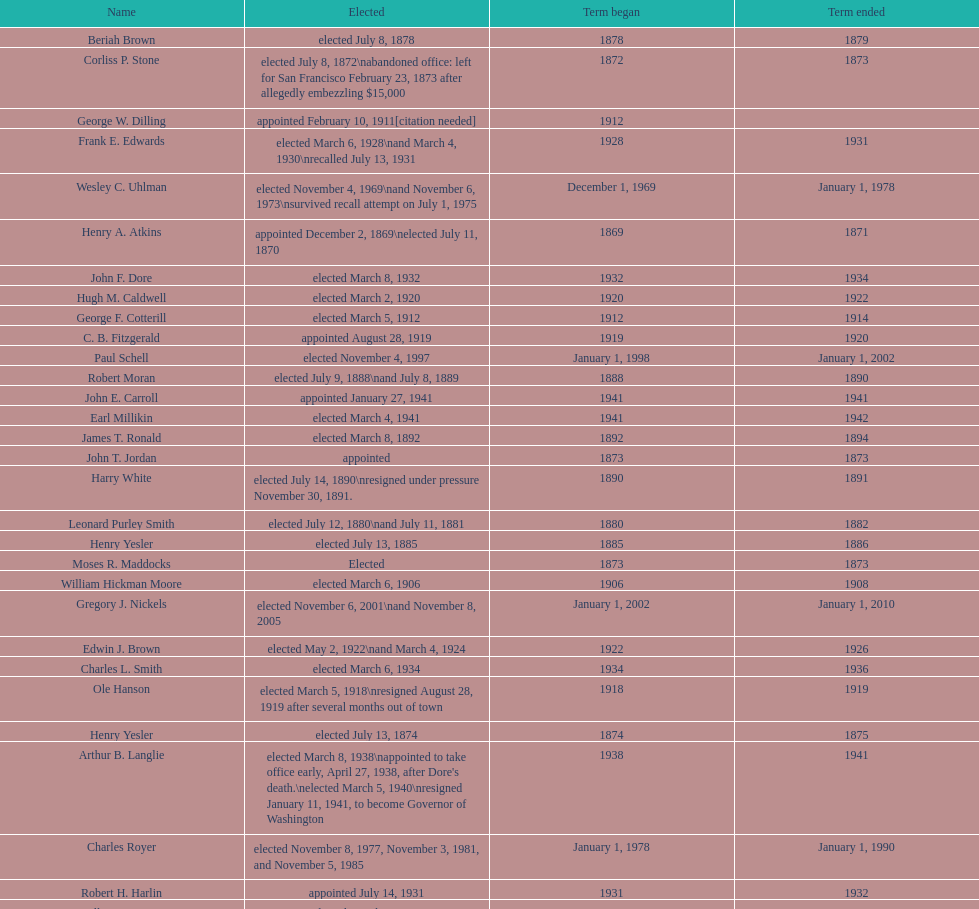What is the number of mayors with the first name of john? 6. 